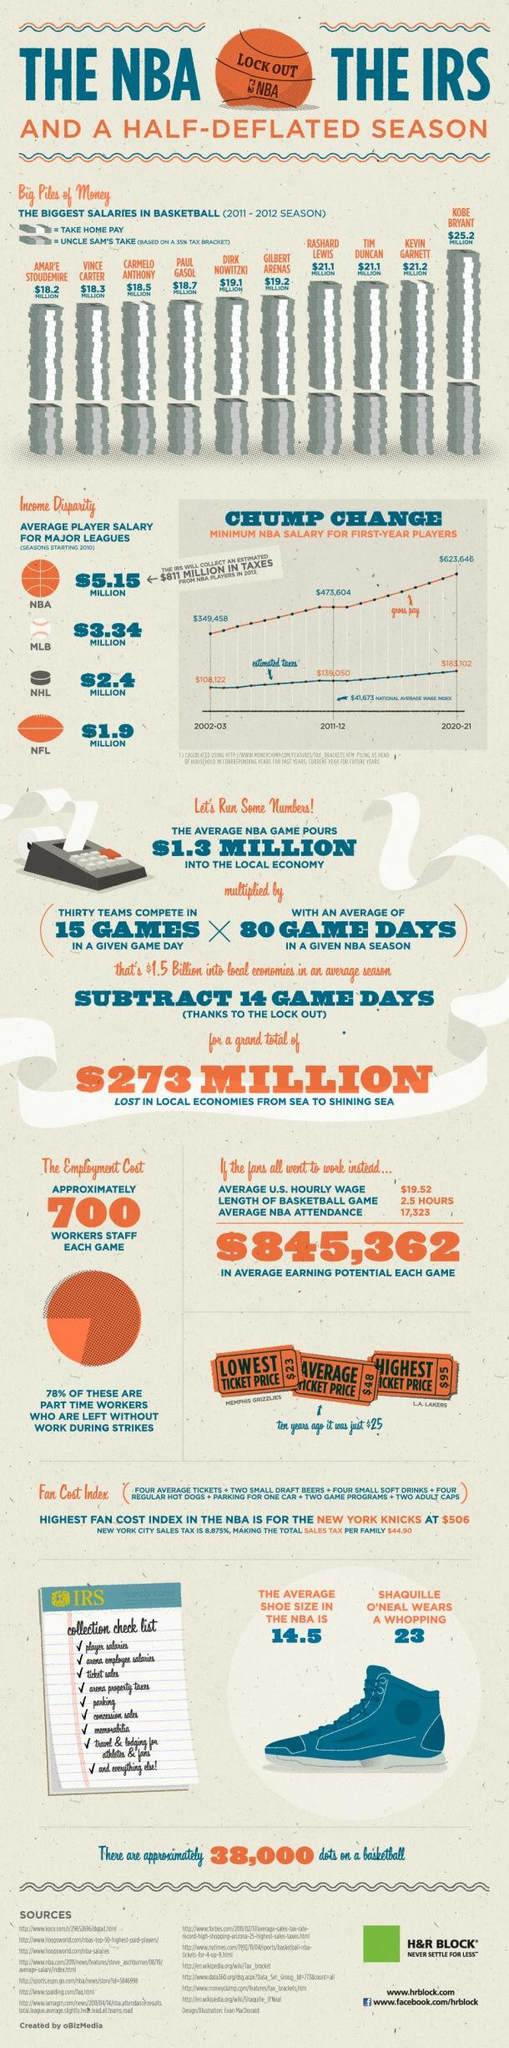Mention a couple of crucial points in this snapshot. The lowest ticket price printed was $23. Shaquille O'Neal's shoe size is 23. The highest ticket price is $95. Carmelo Anthony's salary surpasses that of Amar'e Stoudemire and Vince Carter. There are nine pointers on the collection checklist. 